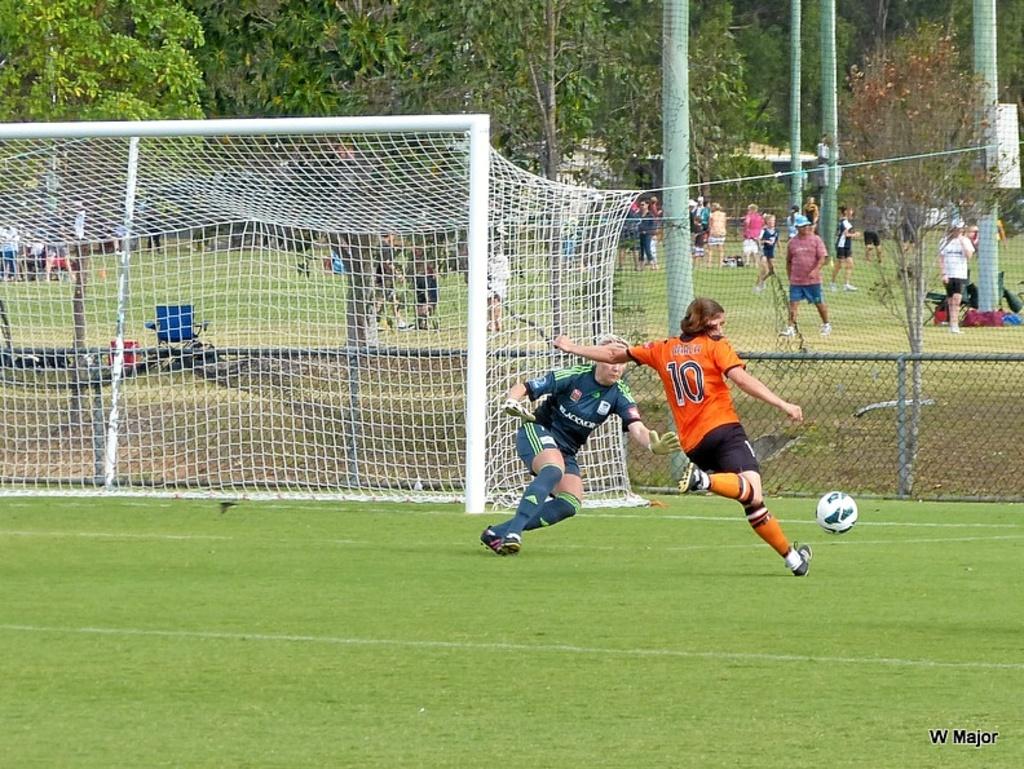What jersey number is seen on the man about to kick the ball?
Your answer should be compact. 10. What does the bottom right text say?
Provide a short and direct response. W major. 